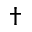Convert formula to latex. <formula><loc_0><loc_0><loc_500><loc_500>\dag</formula> 